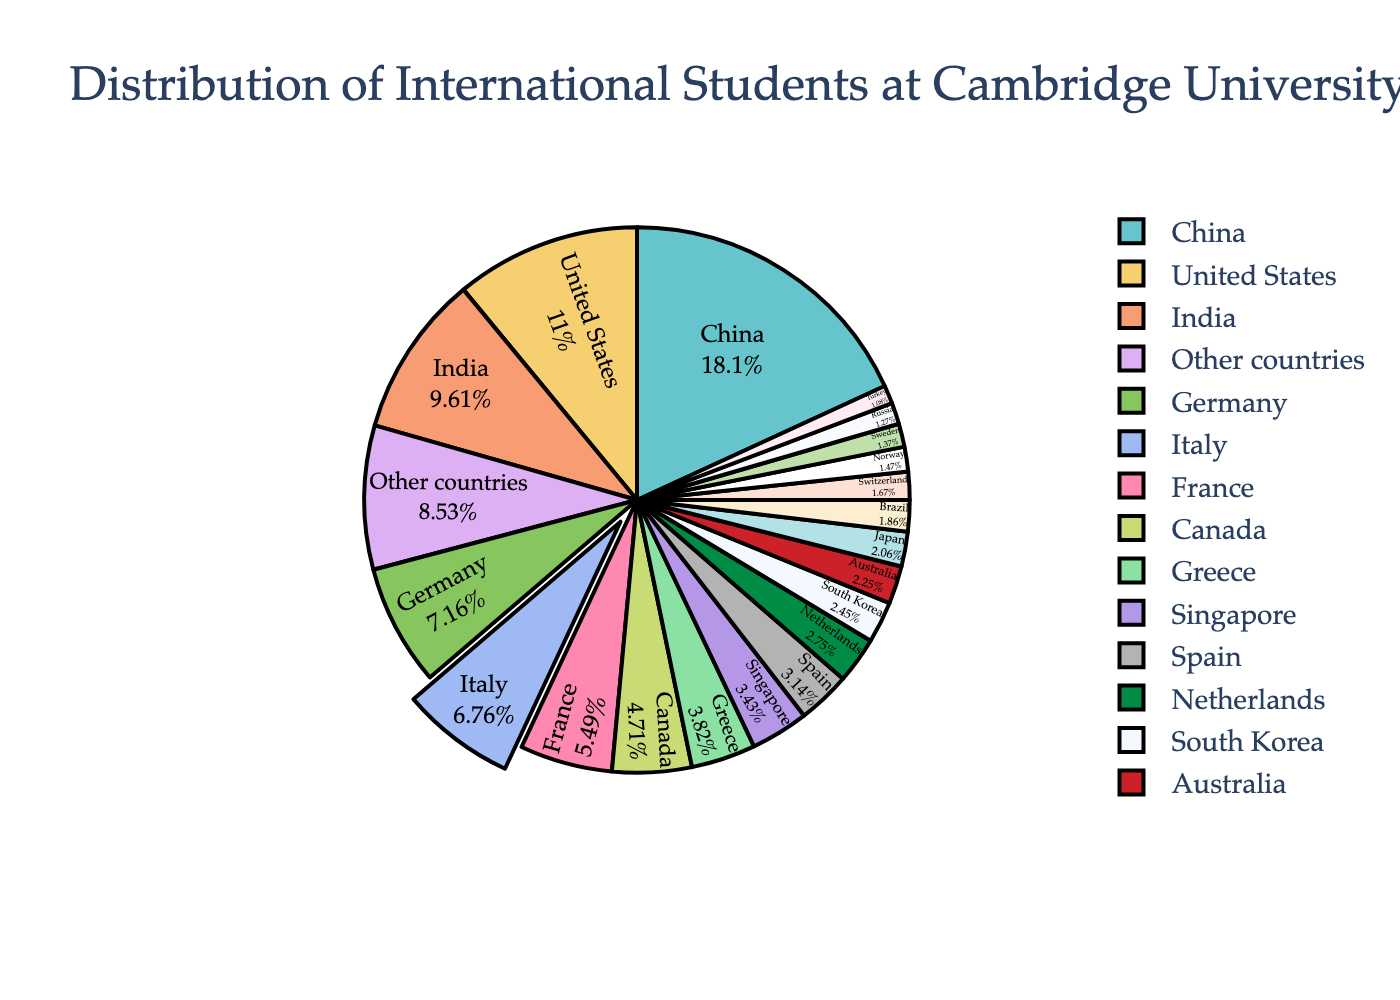What percentage of international students at Cambridge University are from China? To find the percentage of international students from China, look at the corresponding section labeled "China" in the pie chart.
Answer: 18.5% Which country has the second highest percentage of international students at Cambridge University? The country with the second highest percentage is indicated by the segment right next to the largest one labeled "China".
Answer: United States How much higher is the percentage of international students from China compared to Italy? First, find the percentage for China (18.5%) and Italy (6.9%) in the pie chart. Subtract Italy's percentage from China's percentage: 18.5% - 6.9% = 11.6%.
Answer: 11.6% Are there more international students from France or Canada? Compare the segments labeled "France" and "Canada". The chart shows that France has 5.6% and Canada has 4.8%, so there are more international students from France.
Answer: France Which three countries have the smallest percentage of international students? Identify the three smallest segments in the pie chart. The smallest percentages are 1.1% (Turkey), 1.3% (Russia), and 1.4% (Sweden).
Answer: Turkey, Russia, Sweden What is the combined percentage of international students from Germany, France, and Italy? Add the percentages for Germany (7.3%), France (5.6%), and Italy (6.9%): 7.3% + 5.6% + 6.9% = 19.8%.
Answer: 19.8% Which country has a similar percentage to Brazil? Identify the segment for Brazil (1.9%) and look for another segment with a close percentage. Switzerland, at 1.7%, is the closest.
Answer: Switzerland How does the percentage of students from Singapore compare to those from Greece? The percentage for Singapore is 3.5% and for Greece is 3.9%. By comparing the two, Greece has a slightly higher percentage.
Answer: Greece What notable visual feature distinguishes Italy's segment compared to others? The segment for Italy is visually distinct because it is pulled outward from the pie chart, making it more prominent.
Answer: It is pulled outward How many countries have a percentage of international students higher than 5%? Identify and count the segments with percentages higher than 5%: China, United States, India, Germany, Italy, and France. There are 6 such countries.
Answer: 6 